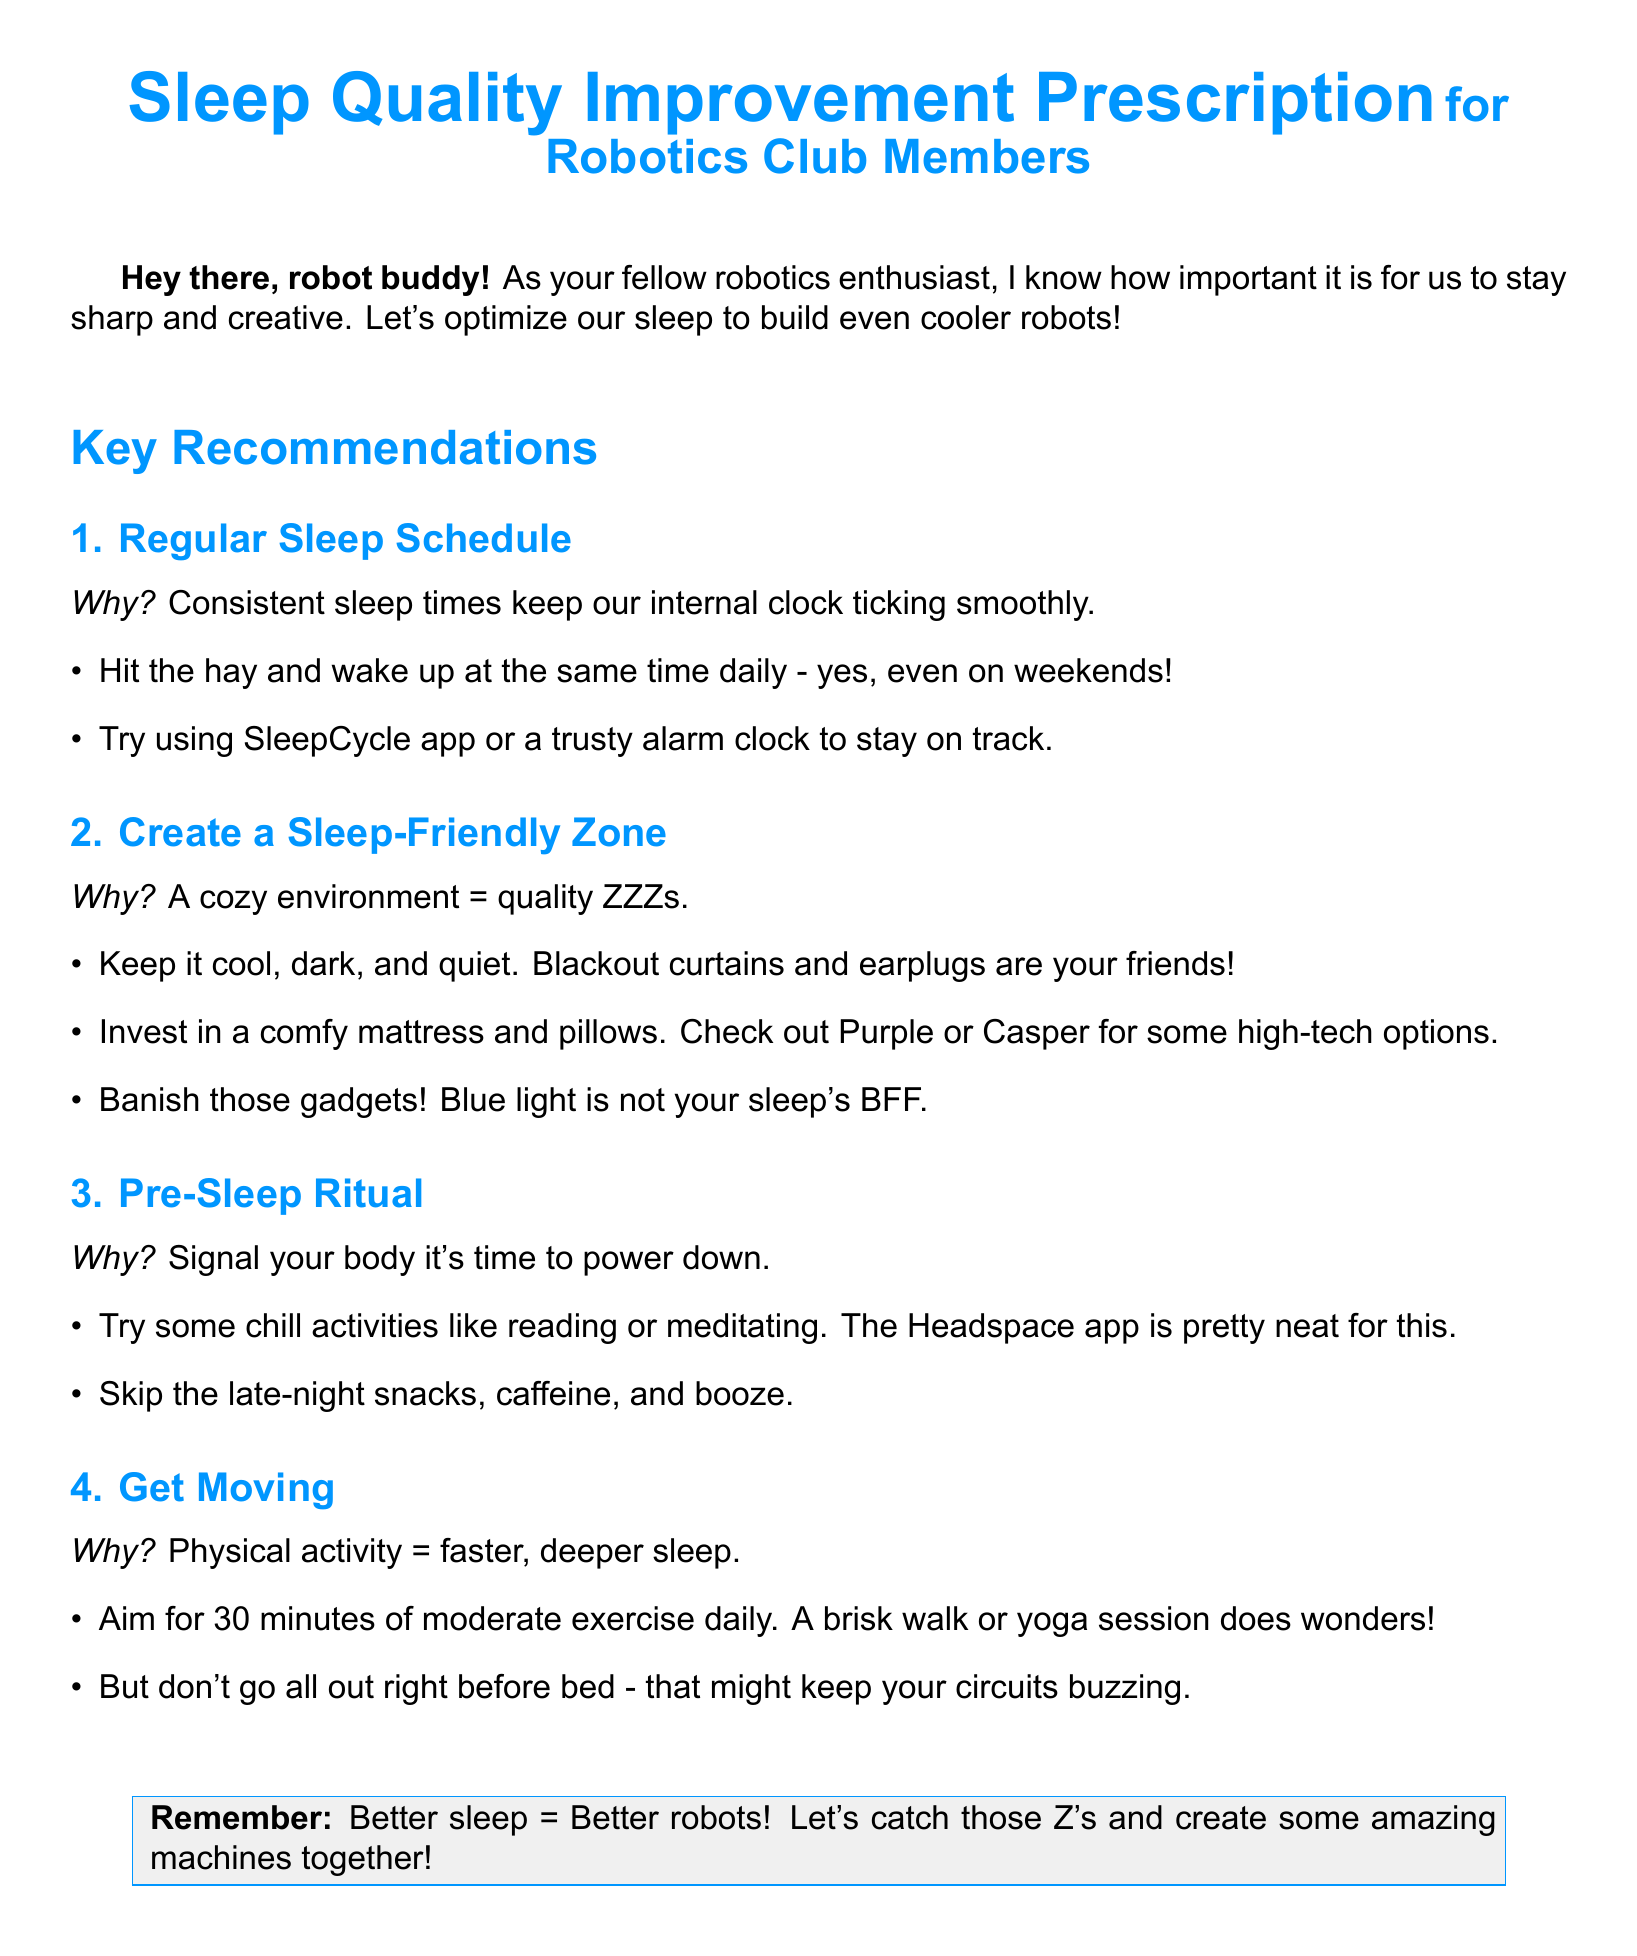What is the document title? The title is prominently displayed at the top of the document, emphasizing sleep quality improvement for robotics club members.
Answer: Sleep Quality Improvement Prescription What color is used for headings in the document? The document specifies that headings are formatted using a custom color called robotblue.
Answer: Robotblue How often should robotics club members aim to wake up? The recommendation suggests waking up at the same time daily, which includes weekends.
Answer: Daily What is one recommended app for keeping track of sleep? The document mentions a specific app that helps with sleep tracking as part of the recommendations.
Answer: SleepCycle What type of environment is suggested for better sleep? The document highlights certain environmental conditions that contribute to quality sleep.
Answer: Cool, dark, and quiet What activity is advised to avoid late at night? The recommendations explicitly list certain late-night consumption habits that should be avoided for better sleep.
Answer: Caffeine How long should members aim to exercise daily? The exercise recommendation specifies a particular duration that contributes positively to sleep quality.
Answer: 30 minutes What should you skip as part of the pre-sleep ritual? The document lists specific items that should be omitted in the lead-up to bedtime to improve sleep quality.
Answer: Late-night snacks What is the overall theme of the document? The document centers around enhancing sleep quality for a specific group, linking it to their activities.
Answer: Sleep quality improvement 